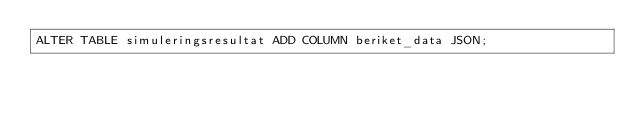Convert code to text. <code><loc_0><loc_0><loc_500><loc_500><_SQL_>ALTER TABLE simuleringsresultat ADD COLUMN beriket_data JSON;
</code> 